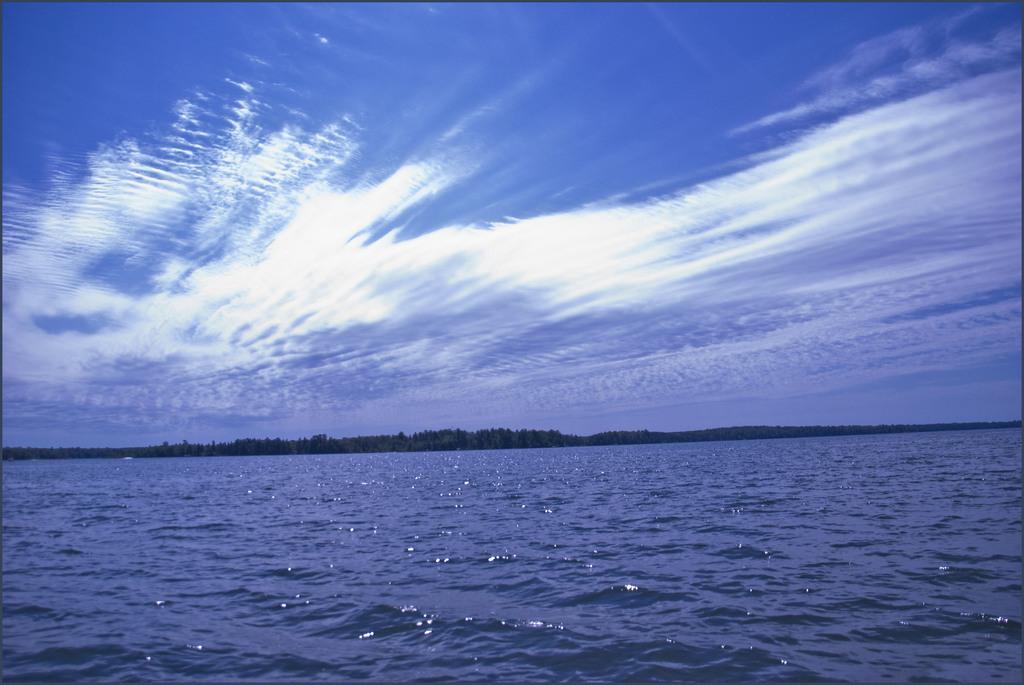Can you describe this image briefly? In this picture we can see water at the bottom, those are looking like trees in the background, we can see the sky at the top of the picture. 